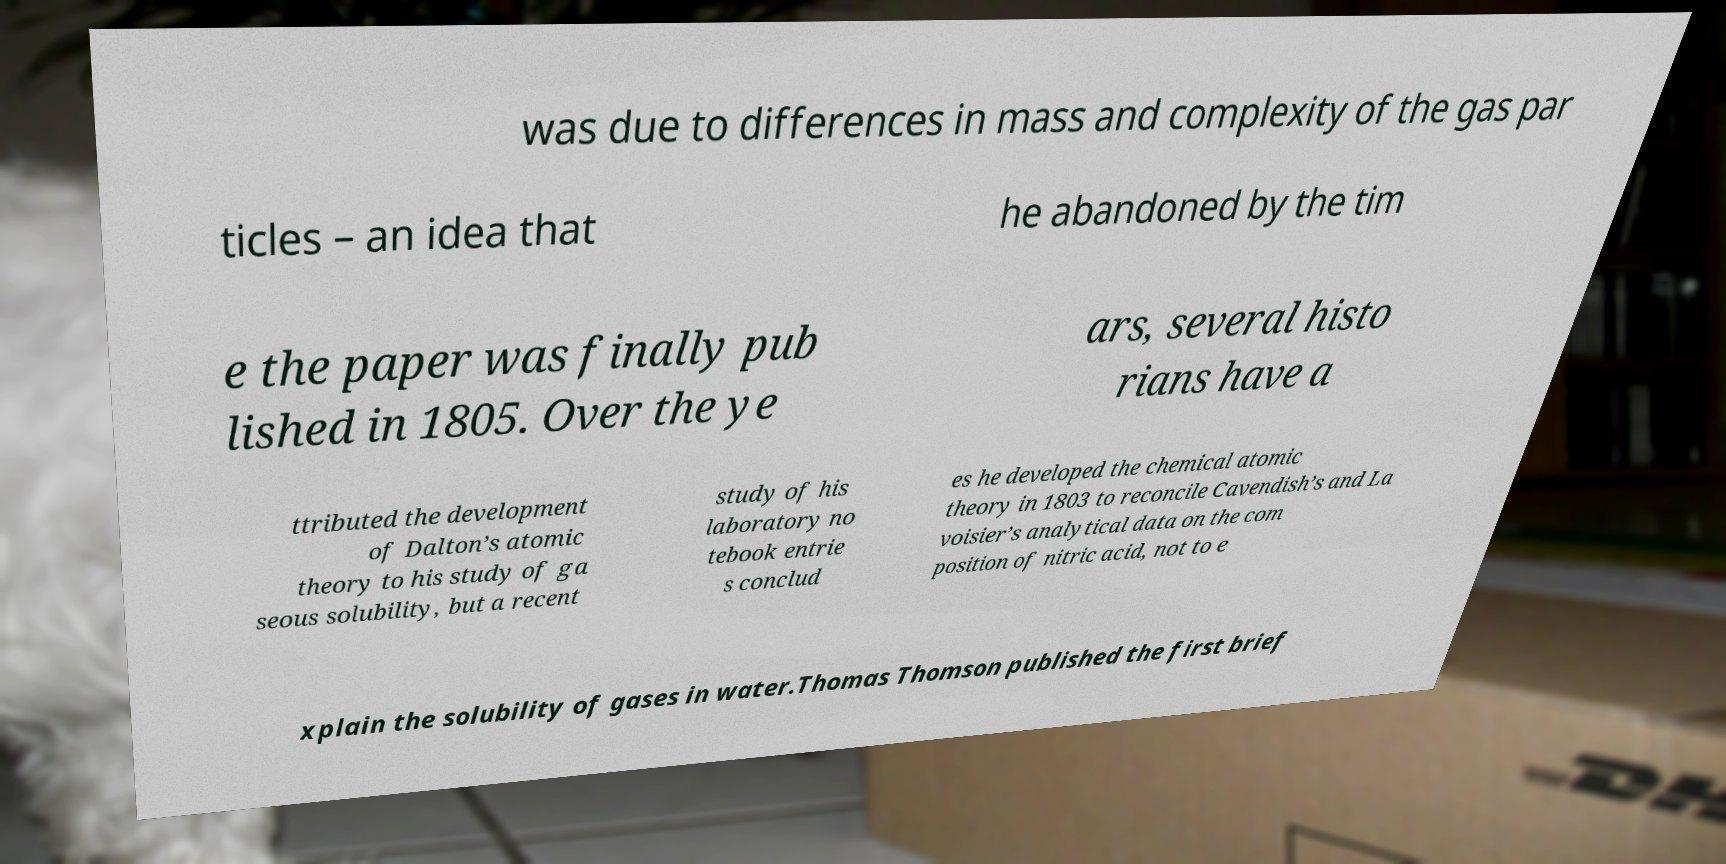For documentation purposes, I need the text within this image transcribed. Could you provide that? was due to differences in mass and complexity of the gas par ticles – an idea that he abandoned by the tim e the paper was finally pub lished in 1805. Over the ye ars, several histo rians have a ttributed the development of Dalton’s atomic theory to his study of ga seous solubility, but a recent study of his laboratory no tebook entrie s conclud es he developed the chemical atomic theory in 1803 to reconcile Cavendish’s and La voisier’s analytical data on the com position of nitric acid, not to e xplain the solubility of gases in water.Thomas Thomson published the first brief 